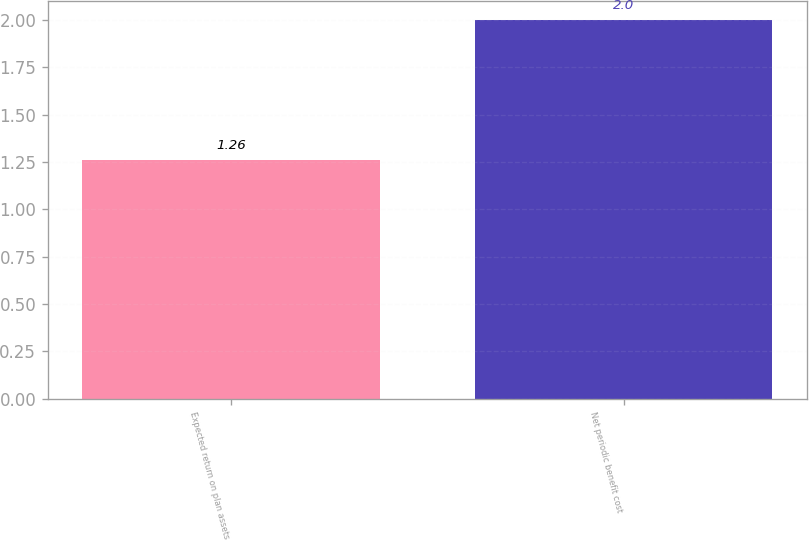<chart> <loc_0><loc_0><loc_500><loc_500><bar_chart><fcel>Expected return on plan assets<fcel>Net periodic benefit cost<nl><fcel>1.26<fcel>2<nl></chart> 